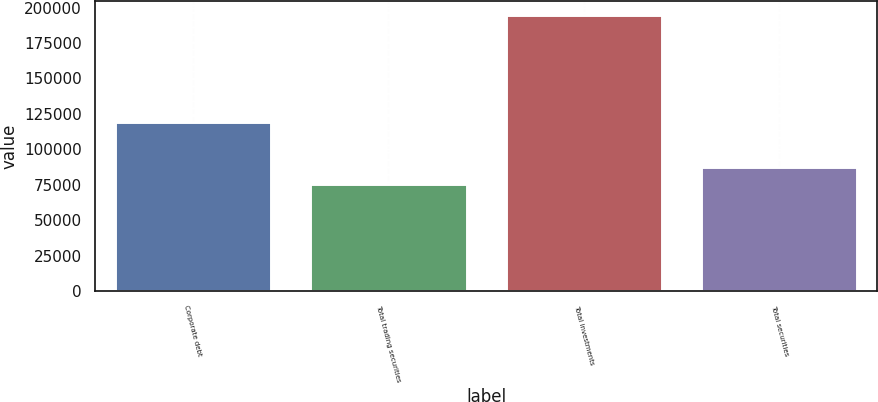Convert chart to OTSL. <chart><loc_0><loc_0><loc_500><loc_500><bar_chart><fcel>Corporate debt<fcel>Total trading securities<fcel>Total investments<fcel>Total securities<nl><fcel>119073<fcel>75606<fcel>194679<fcel>87513.3<nl></chart> 